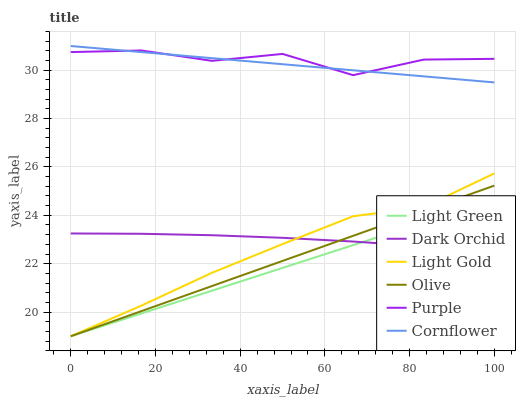Does Light Green have the minimum area under the curve?
Answer yes or no. Yes. Does Purple have the maximum area under the curve?
Answer yes or no. Yes. Does Dark Orchid have the minimum area under the curve?
Answer yes or no. No. Does Dark Orchid have the maximum area under the curve?
Answer yes or no. No. Is Olive the smoothest?
Answer yes or no. Yes. Is Purple the roughest?
Answer yes or no. Yes. Is Dark Orchid the smoothest?
Answer yes or no. No. Is Dark Orchid the roughest?
Answer yes or no. No. Does Light Green have the lowest value?
Answer yes or no. Yes. Does Dark Orchid have the lowest value?
Answer yes or no. No. Does Cornflower have the highest value?
Answer yes or no. Yes. Does Purple have the highest value?
Answer yes or no. No. Is Light Gold less than Cornflower?
Answer yes or no. Yes. Is Purple greater than Olive?
Answer yes or no. Yes. Does Olive intersect Light Green?
Answer yes or no. Yes. Is Olive less than Light Green?
Answer yes or no. No. Is Olive greater than Light Green?
Answer yes or no. No. Does Light Gold intersect Cornflower?
Answer yes or no. No. 